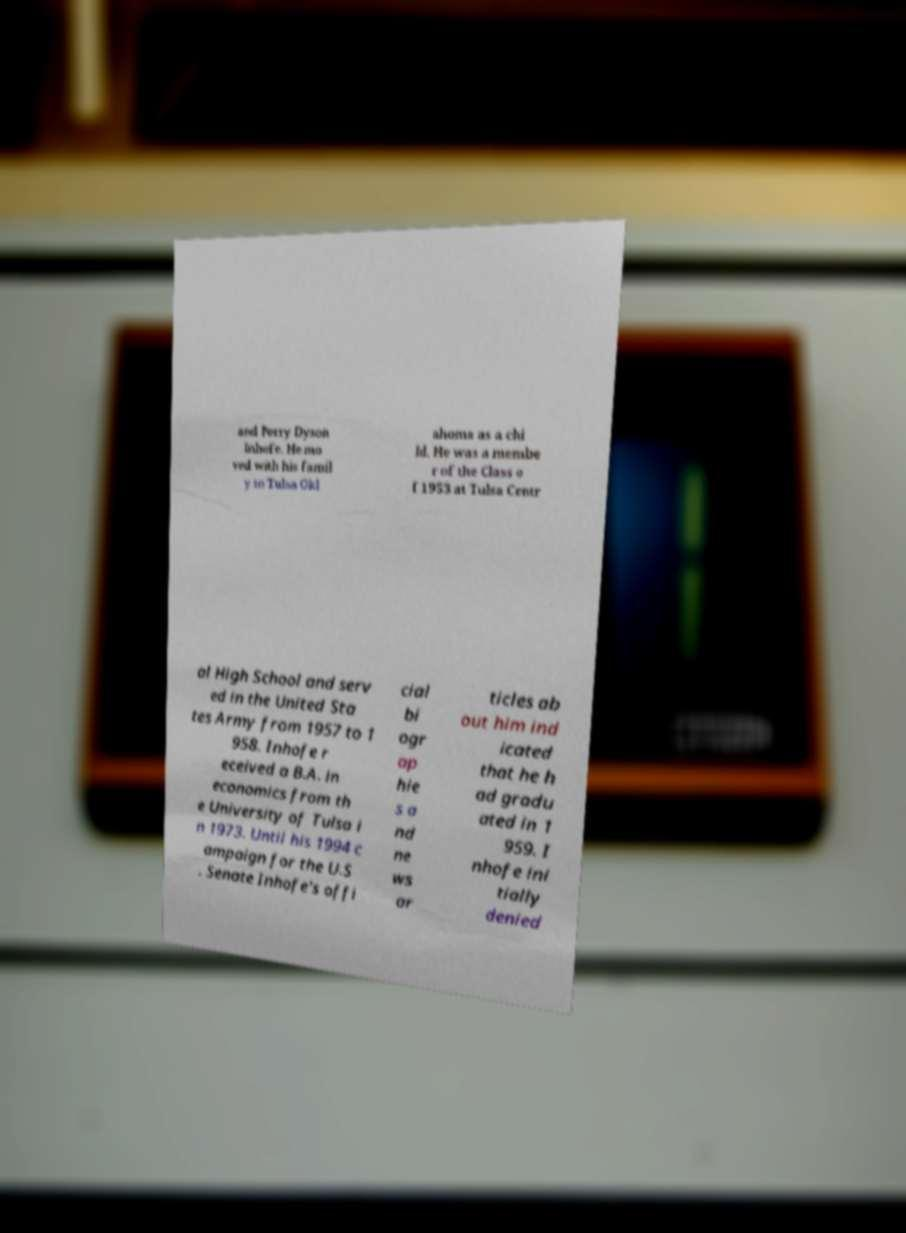Please identify and transcribe the text found in this image. and Perry Dyson Inhofe. He mo ved with his famil y to Tulsa Okl ahoma as a chi ld. He was a membe r of the Class o f 1953 at Tulsa Centr al High School and serv ed in the United Sta tes Army from 1957 to 1 958. Inhofe r eceived a B.A. in economics from th e University of Tulsa i n 1973. Until his 1994 c ampaign for the U.S . Senate Inhofe's offi cial bi ogr ap hie s a nd ne ws ar ticles ab out him ind icated that he h ad gradu ated in 1 959. I nhofe ini tially denied 